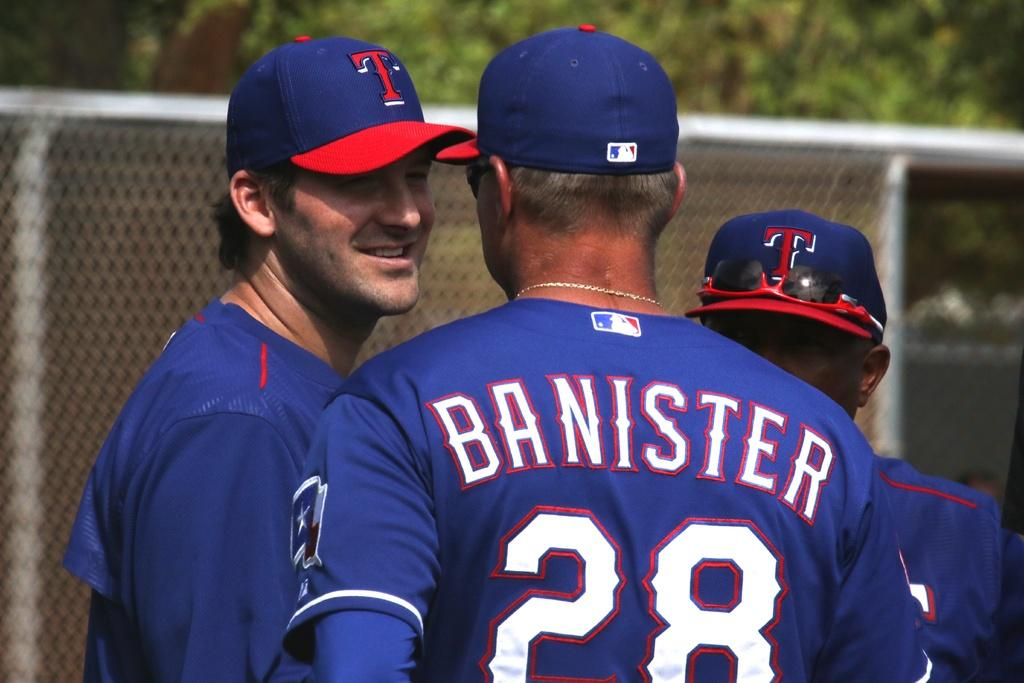Provide a one-sentence caption for the provided image. three men in blue shirts, one with the number 28 on the back. 